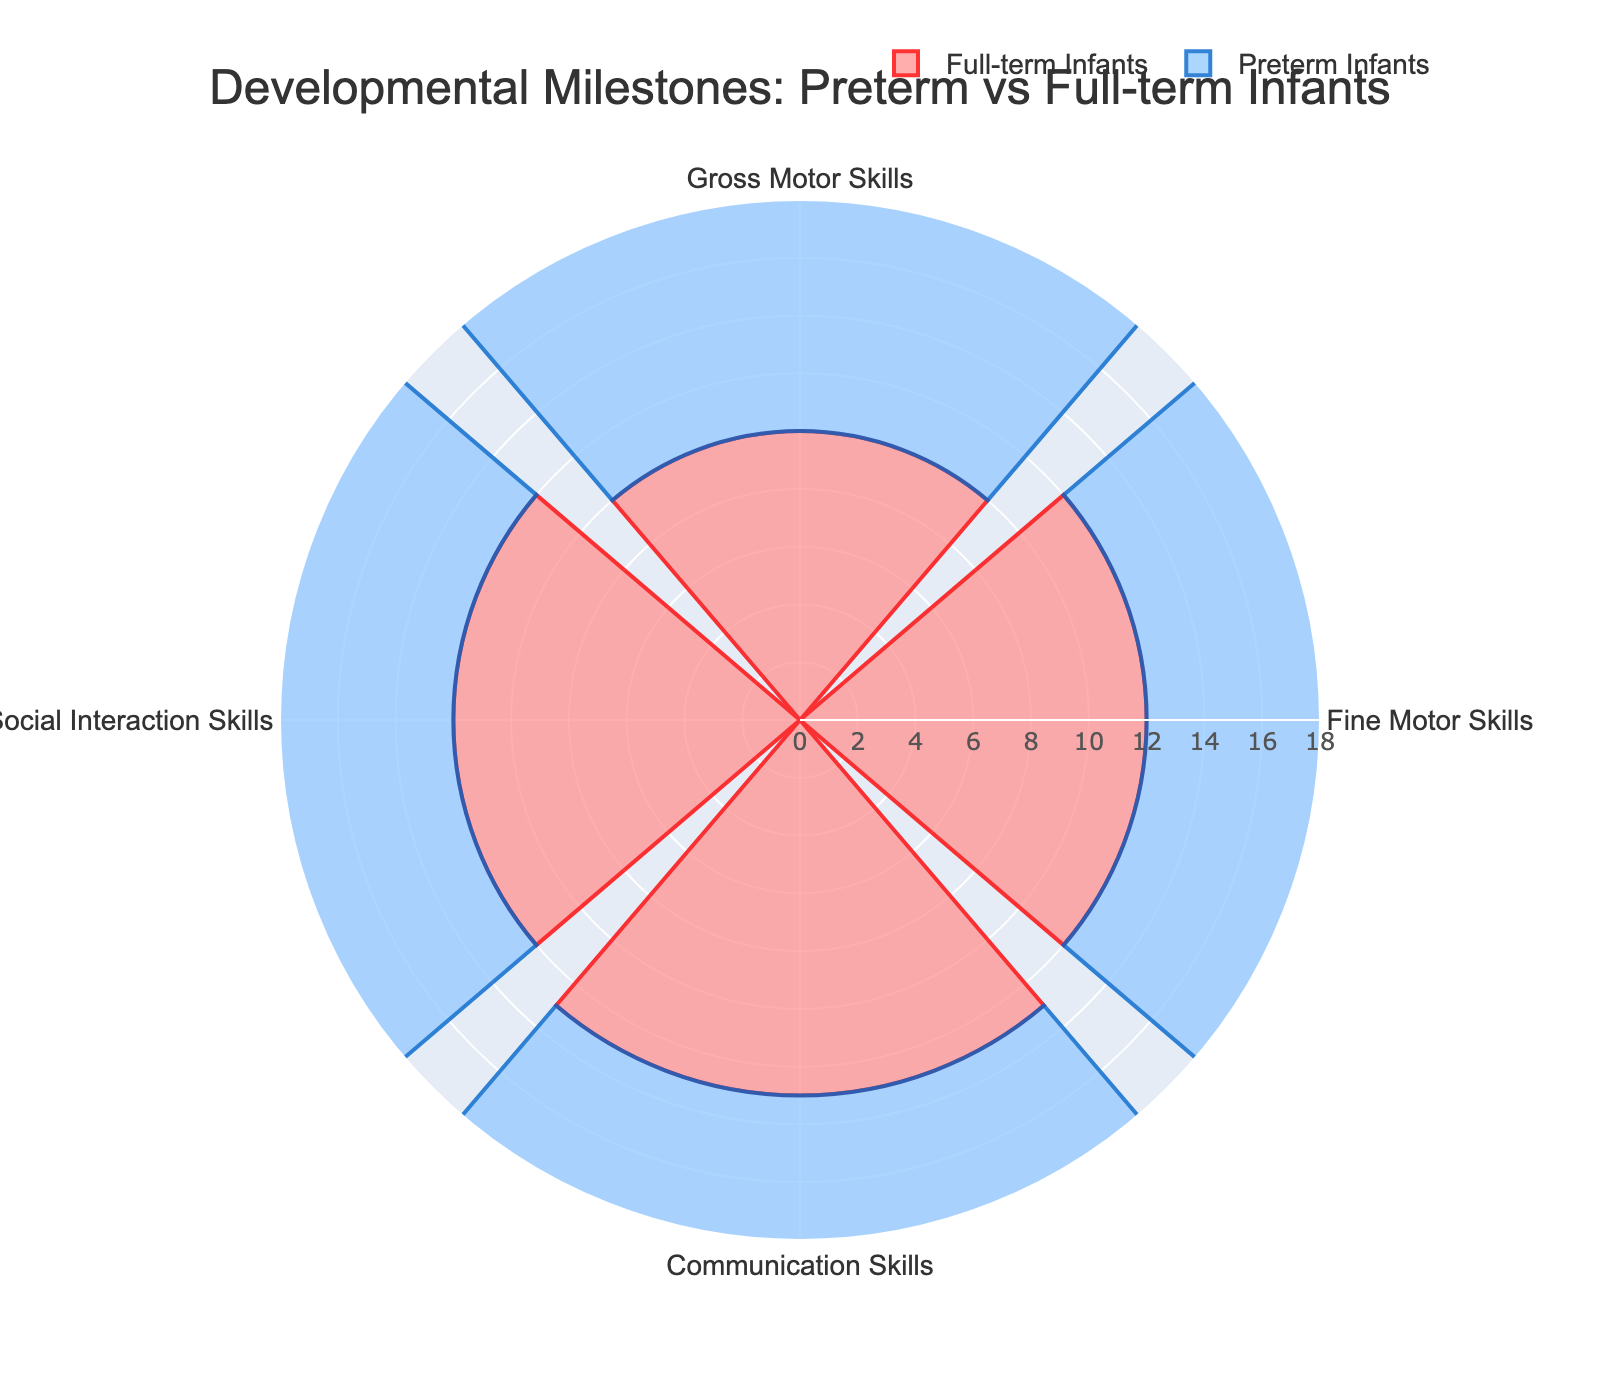What's the title of the chart? The title is usually prominently displayed at the top of the chart. It provides an overview of what the chart represents. In this case, the title is "Developmental Milestones: Preterm vs Full-term Infants".
Answer: Developmental Milestones: Preterm vs Full-term Infants What is the difference in months for achieving Gross Motor Skills between full-term and preterm infants? Look at the Gross Motor Skills values for both groups. Full-term infants achieve this milestone at 10 months and preterm infants at 12 months. Subtract the two values (12 - 10).
Answer: 2 months Which milestone has the largest difference between full-term and preterm infants? Compare the differences for each milestone: Gross Motor Skills (2 months), Fine Motor Skills (2 months), Communication Skills (3 months), Social Interaction Skills (3 months). The largest difference is 3 months.
Answer: Communication Skills and Social Interaction Skills What is the total sum of months for full-term infants across all milestones? Add the values for each milestone for full-term infants: 10 (Gross Motor Skills) + 12 (Fine Motor Skills) + 13 (Communication Skills) + 12 (Social Interaction Skills).
Answer: 47 months Which infant group achieves Fine Motor Skills later, and by how many months? Compare the Fine Motor Skills values for full-term (12 months) and preterm infants (14 months). Preterm infants achieve it later. Subtract the two values (14 - 12).
Answer: Preterm infants, by 2 months How many milestones are depicted in the chart? Count the unique categories listed on the chart. There are four milestones: Gross Motor Skills, Fine Motor Skills, Communication Skills, and Social Interaction Skills.
Answer: 4 milestones Is there any milestone where preterm infants achieve the milestone earlier than full-term infants? Compare the months for each milestone between full-term and preterm infants. For all milestones (Gross Motor Skills, Fine Motor Skills, Communication Skills, Social Interaction Skills), preterm infants achieve them later.
Answer: No What is the average age of achieving Communication Skills for both full-term and preterm infants? Add the ages for full-term (13 months) and preterm infants (16 months), then divide by 2. (13 + 16) / 2.
Answer: 14.5 months Which group has a higher percentage of reaching milestones later in all categories, full-term or preterm infants? For each milestone, compare the months. Preterm infants achieve each milestone later compared to full-term infants.
Answer: Preterm infants How much longer, in total, do preterm infants take to reach all milestones compared to full-term infants? Calculate the total months for both groups then find the difference: Full-term infants (47 months), Preterm infants (57 months). Subtract the values: 57 - 47.
Answer: 10 months 